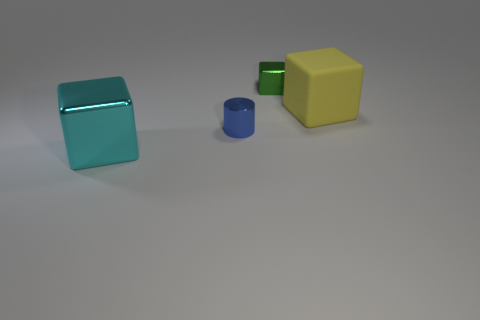What size is the yellow block that is behind the tiny blue metallic thing?
Your answer should be very brief. Large. Is the number of small cubes on the left side of the cylinder less than the number of green cylinders?
Make the answer very short. No. Is the color of the metal cylinder the same as the small metallic cube?
Your answer should be compact. No. Is there anything else that is the same shape as the tiny blue object?
Your response must be concise. No. Is the number of tiny metal objects less than the number of tiny red shiny spheres?
Your response must be concise. No. What color is the shiny block that is in front of the metal cube that is behind the large yellow matte thing?
Offer a terse response. Cyan. There is a large thing on the right side of the big cube that is left of the tiny object that is in front of the tiny block; what is it made of?
Keep it short and to the point. Rubber. There is a shiny thing on the left side of the blue cylinder; is it the same size as the blue thing?
Provide a succinct answer. No. There is a big object behind the cyan metal object; what material is it?
Provide a succinct answer. Rubber. Is the number of red shiny cubes greater than the number of large yellow blocks?
Your answer should be compact. No. 